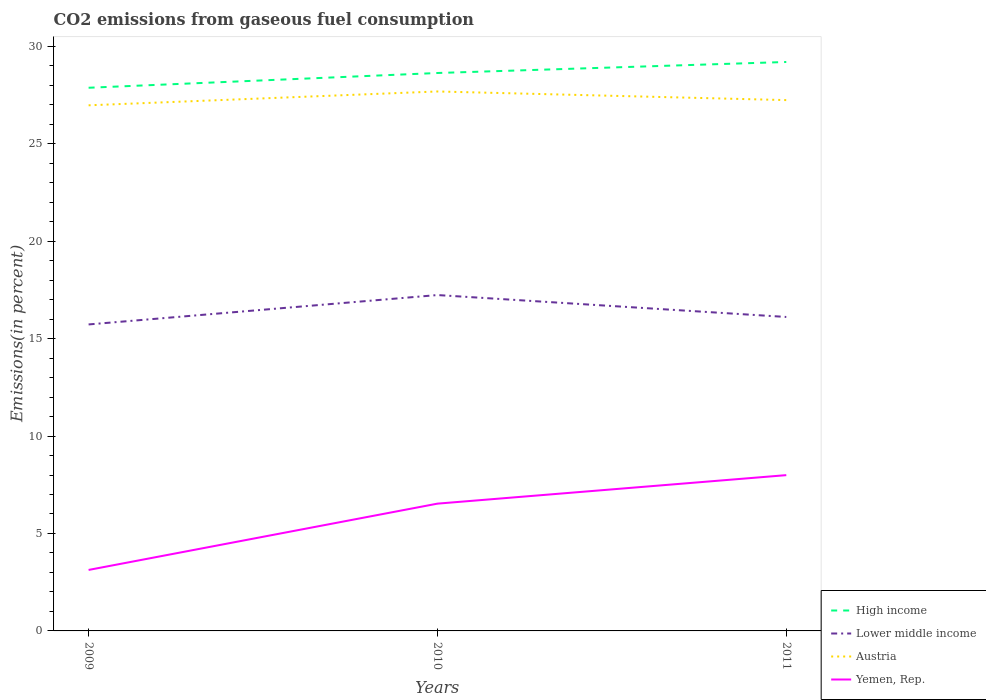Does the line corresponding to Lower middle income intersect with the line corresponding to High income?
Your answer should be very brief. No. Across all years, what is the maximum total CO2 emitted in High income?
Your answer should be compact. 27.87. What is the total total CO2 emitted in Yemen, Rep. in the graph?
Give a very brief answer. -1.46. What is the difference between the highest and the second highest total CO2 emitted in Yemen, Rep.?
Your answer should be compact. 4.86. What is the difference between the highest and the lowest total CO2 emitted in Yemen, Rep.?
Provide a succinct answer. 2. Is the total CO2 emitted in High income strictly greater than the total CO2 emitted in Yemen, Rep. over the years?
Provide a succinct answer. No. How many lines are there?
Your response must be concise. 4. Are the values on the major ticks of Y-axis written in scientific E-notation?
Ensure brevity in your answer.  No. Does the graph contain grids?
Ensure brevity in your answer.  No. Where does the legend appear in the graph?
Make the answer very short. Bottom right. How many legend labels are there?
Your response must be concise. 4. How are the legend labels stacked?
Provide a short and direct response. Vertical. What is the title of the graph?
Make the answer very short. CO2 emissions from gaseous fuel consumption. What is the label or title of the X-axis?
Ensure brevity in your answer.  Years. What is the label or title of the Y-axis?
Ensure brevity in your answer.  Emissions(in percent). What is the Emissions(in percent) in High income in 2009?
Keep it short and to the point. 27.87. What is the Emissions(in percent) of Lower middle income in 2009?
Make the answer very short. 15.73. What is the Emissions(in percent) in Austria in 2009?
Offer a terse response. 26.97. What is the Emissions(in percent) of Yemen, Rep. in 2009?
Offer a terse response. 3.13. What is the Emissions(in percent) in High income in 2010?
Your answer should be very brief. 28.63. What is the Emissions(in percent) of Lower middle income in 2010?
Make the answer very short. 17.23. What is the Emissions(in percent) of Austria in 2010?
Make the answer very short. 27.68. What is the Emissions(in percent) in Yemen, Rep. in 2010?
Offer a very short reply. 6.53. What is the Emissions(in percent) in High income in 2011?
Provide a succinct answer. 29.19. What is the Emissions(in percent) of Lower middle income in 2011?
Your answer should be compact. 16.11. What is the Emissions(in percent) of Austria in 2011?
Offer a very short reply. 27.24. What is the Emissions(in percent) in Yemen, Rep. in 2011?
Provide a short and direct response. 7.99. Across all years, what is the maximum Emissions(in percent) of High income?
Give a very brief answer. 29.19. Across all years, what is the maximum Emissions(in percent) of Lower middle income?
Keep it short and to the point. 17.23. Across all years, what is the maximum Emissions(in percent) of Austria?
Ensure brevity in your answer.  27.68. Across all years, what is the maximum Emissions(in percent) of Yemen, Rep.?
Provide a succinct answer. 7.99. Across all years, what is the minimum Emissions(in percent) of High income?
Provide a short and direct response. 27.87. Across all years, what is the minimum Emissions(in percent) of Lower middle income?
Provide a short and direct response. 15.73. Across all years, what is the minimum Emissions(in percent) of Austria?
Provide a succinct answer. 26.97. Across all years, what is the minimum Emissions(in percent) in Yemen, Rep.?
Your answer should be compact. 3.13. What is the total Emissions(in percent) in High income in the graph?
Offer a very short reply. 85.69. What is the total Emissions(in percent) of Lower middle income in the graph?
Offer a terse response. 49.07. What is the total Emissions(in percent) in Austria in the graph?
Make the answer very short. 81.89. What is the total Emissions(in percent) in Yemen, Rep. in the graph?
Offer a very short reply. 17.65. What is the difference between the Emissions(in percent) in High income in 2009 and that in 2010?
Your response must be concise. -0.76. What is the difference between the Emissions(in percent) in Lower middle income in 2009 and that in 2010?
Your answer should be very brief. -1.51. What is the difference between the Emissions(in percent) in Austria in 2009 and that in 2010?
Your response must be concise. -0.71. What is the difference between the Emissions(in percent) in Yemen, Rep. in 2009 and that in 2010?
Ensure brevity in your answer.  -3.4. What is the difference between the Emissions(in percent) of High income in 2009 and that in 2011?
Make the answer very short. -1.32. What is the difference between the Emissions(in percent) of Lower middle income in 2009 and that in 2011?
Provide a succinct answer. -0.38. What is the difference between the Emissions(in percent) of Austria in 2009 and that in 2011?
Your answer should be very brief. -0.27. What is the difference between the Emissions(in percent) of Yemen, Rep. in 2009 and that in 2011?
Keep it short and to the point. -4.86. What is the difference between the Emissions(in percent) of High income in 2010 and that in 2011?
Your response must be concise. -0.57. What is the difference between the Emissions(in percent) in Lower middle income in 2010 and that in 2011?
Give a very brief answer. 1.12. What is the difference between the Emissions(in percent) in Austria in 2010 and that in 2011?
Provide a short and direct response. 0.44. What is the difference between the Emissions(in percent) of Yemen, Rep. in 2010 and that in 2011?
Your response must be concise. -1.46. What is the difference between the Emissions(in percent) of High income in 2009 and the Emissions(in percent) of Lower middle income in 2010?
Your answer should be compact. 10.64. What is the difference between the Emissions(in percent) of High income in 2009 and the Emissions(in percent) of Austria in 2010?
Your answer should be very brief. 0.19. What is the difference between the Emissions(in percent) of High income in 2009 and the Emissions(in percent) of Yemen, Rep. in 2010?
Your answer should be very brief. 21.34. What is the difference between the Emissions(in percent) in Lower middle income in 2009 and the Emissions(in percent) in Austria in 2010?
Ensure brevity in your answer.  -11.95. What is the difference between the Emissions(in percent) in Lower middle income in 2009 and the Emissions(in percent) in Yemen, Rep. in 2010?
Keep it short and to the point. 9.2. What is the difference between the Emissions(in percent) in Austria in 2009 and the Emissions(in percent) in Yemen, Rep. in 2010?
Offer a very short reply. 20.44. What is the difference between the Emissions(in percent) of High income in 2009 and the Emissions(in percent) of Lower middle income in 2011?
Offer a terse response. 11.76. What is the difference between the Emissions(in percent) in High income in 2009 and the Emissions(in percent) in Austria in 2011?
Offer a very short reply. 0.63. What is the difference between the Emissions(in percent) in High income in 2009 and the Emissions(in percent) in Yemen, Rep. in 2011?
Make the answer very short. 19.88. What is the difference between the Emissions(in percent) in Lower middle income in 2009 and the Emissions(in percent) in Austria in 2011?
Make the answer very short. -11.51. What is the difference between the Emissions(in percent) in Lower middle income in 2009 and the Emissions(in percent) in Yemen, Rep. in 2011?
Ensure brevity in your answer.  7.73. What is the difference between the Emissions(in percent) in Austria in 2009 and the Emissions(in percent) in Yemen, Rep. in 2011?
Your answer should be very brief. 18.98. What is the difference between the Emissions(in percent) in High income in 2010 and the Emissions(in percent) in Lower middle income in 2011?
Your answer should be very brief. 12.52. What is the difference between the Emissions(in percent) of High income in 2010 and the Emissions(in percent) of Austria in 2011?
Your response must be concise. 1.39. What is the difference between the Emissions(in percent) in High income in 2010 and the Emissions(in percent) in Yemen, Rep. in 2011?
Your response must be concise. 20.63. What is the difference between the Emissions(in percent) in Lower middle income in 2010 and the Emissions(in percent) in Austria in 2011?
Your answer should be very brief. -10. What is the difference between the Emissions(in percent) in Lower middle income in 2010 and the Emissions(in percent) in Yemen, Rep. in 2011?
Your response must be concise. 9.24. What is the difference between the Emissions(in percent) of Austria in 2010 and the Emissions(in percent) of Yemen, Rep. in 2011?
Ensure brevity in your answer.  19.69. What is the average Emissions(in percent) of High income per year?
Your response must be concise. 28.56. What is the average Emissions(in percent) of Lower middle income per year?
Ensure brevity in your answer.  16.36. What is the average Emissions(in percent) of Austria per year?
Your answer should be compact. 27.3. What is the average Emissions(in percent) of Yemen, Rep. per year?
Your response must be concise. 5.88. In the year 2009, what is the difference between the Emissions(in percent) of High income and Emissions(in percent) of Lower middle income?
Provide a succinct answer. 12.14. In the year 2009, what is the difference between the Emissions(in percent) in High income and Emissions(in percent) in Austria?
Your answer should be compact. 0.9. In the year 2009, what is the difference between the Emissions(in percent) of High income and Emissions(in percent) of Yemen, Rep.?
Provide a succinct answer. 24.74. In the year 2009, what is the difference between the Emissions(in percent) in Lower middle income and Emissions(in percent) in Austria?
Offer a terse response. -11.24. In the year 2009, what is the difference between the Emissions(in percent) in Lower middle income and Emissions(in percent) in Yemen, Rep.?
Offer a terse response. 12.6. In the year 2009, what is the difference between the Emissions(in percent) in Austria and Emissions(in percent) in Yemen, Rep.?
Offer a very short reply. 23.84. In the year 2010, what is the difference between the Emissions(in percent) of High income and Emissions(in percent) of Lower middle income?
Provide a short and direct response. 11.39. In the year 2010, what is the difference between the Emissions(in percent) of High income and Emissions(in percent) of Austria?
Offer a terse response. 0.95. In the year 2010, what is the difference between the Emissions(in percent) in High income and Emissions(in percent) in Yemen, Rep.?
Offer a very short reply. 22.1. In the year 2010, what is the difference between the Emissions(in percent) of Lower middle income and Emissions(in percent) of Austria?
Provide a short and direct response. -10.45. In the year 2010, what is the difference between the Emissions(in percent) in Lower middle income and Emissions(in percent) in Yemen, Rep.?
Your response must be concise. 10.7. In the year 2010, what is the difference between the Emissions(in percent) of Austria and Emissions(in percent) of Yemen, Rep.?
Ensure brevity in your answer.  21.15. In the year 2011, what is the difference between the Emissions(in percent) in High income and Emissions(in percent) in Lower middle income?
Keep it short and to the point. 13.08. In the year 2011, what is the difference between the Emissions(in percent) in High income and Emissions(in percent) in Austria?
Your response must be concise. 1.96. In the year 2011, what is the difference between the Emissions(in percent) in High income and Emissions(in percent) in Yemen, Rep.?
Your answer should be very brief. 21.2. In the year 2011, what is the difference between the Emissions(in percent) in Lower middle income and Emissions(in percent) in Austria?
Provide a short and direct response. -11.13. In the year 2011, what is the difference between the Emissions(in percent) in Lower middle income and Emissions(in percent) in Yemen, Rep.?
Offer a very short reply. 8.12. In the year 2011, what is the difference between the Emissions(in percent) of Austria and Emissions(in percent) of Yemen, Rep.?
Provide a succinct answer. 19.24. What is the ratio of the Emissions(in percent) of High income in 2009 to that in 2010?
Offer a very short reply. 0.97. What is the ratio of the Emissions(in percent) of Lower middle income in 2009 to that in 2010?
Provide a succinct answer. 0.91. What is the ratio of the Emissions(in percent) of Austria in 2009 to that in 2010?
Your answer should be compact. 0.97. What is the ratio of the Emissions(in percent) in Yemen, Rep. in 2009 to that in 2010?
Provide a short and direct response. 0.48. What is the ratio of the Emissions(in percent) in High income in 2009 to that in 2011?
Make the answer very short. 0.95. What is the ratio of the Emissions(in percent) of Lower middle income in 2009 to that in 2011?
Offer a terse response. 0.98. What is the ratio of the Emissions(in percent) of Austria in 2009 to that in 2011?
Provide a short and direct response. 0.99. What is the ratio of the Emissions(in percent) in Yemen, Rep. in 2009 to that in 2011?
Give a very brief answer. 0.39. What is the ratio of the Emissions(in percent) in High income in 2010 to that in 2011?
Give a very brief answer. 0.98. What is the ratio of the Emissions(in percent) of Lower middle income in 2010 to that in 2011?
Give a very brief answer. 1.07. What is the ratio of the Emissions(in percent) of Austria in 2010 to that in 2011?
Give a very brief answer. 1.02. What is the ratio of the Emissions(in percent) in Yemen, Rep. in 2010 to that in 2011?
Offer a terse response. 0.82. What is the difference between the highest and the second highest Emissions(in percent) in High income?
Provide a short and direct response. 0.57. What is the difference between the highest and the second highest Emissions(in percent) in Lower middle income?
Keep it short and to the point. 1.12. What is the difference between the highest and the second highest Emissions(in percent) of Austria?
Offer a very short reply. 0.44. What is the difference between the highest and the second highest Emissions(in percent) in Yemen, Rep.?
Offer a terse response. 1.46. What is the difference between the highest and the lowest Emissions(in percent) of High income?
Your response must be concise. 1.32. What is the difference between the highest and the lowest Emissions(in percent) in Lower middle income?
Provide a short and direct response. 1.51. What is the difference between the highest and the lowest Emissions(in percent) of Austria?
Ensure brevity in your answer.  0.71. What is the difference between the highest and the lowest Emissions(in percent) in Yemen, Rep.?
Your answer should be compact. 4.86. 